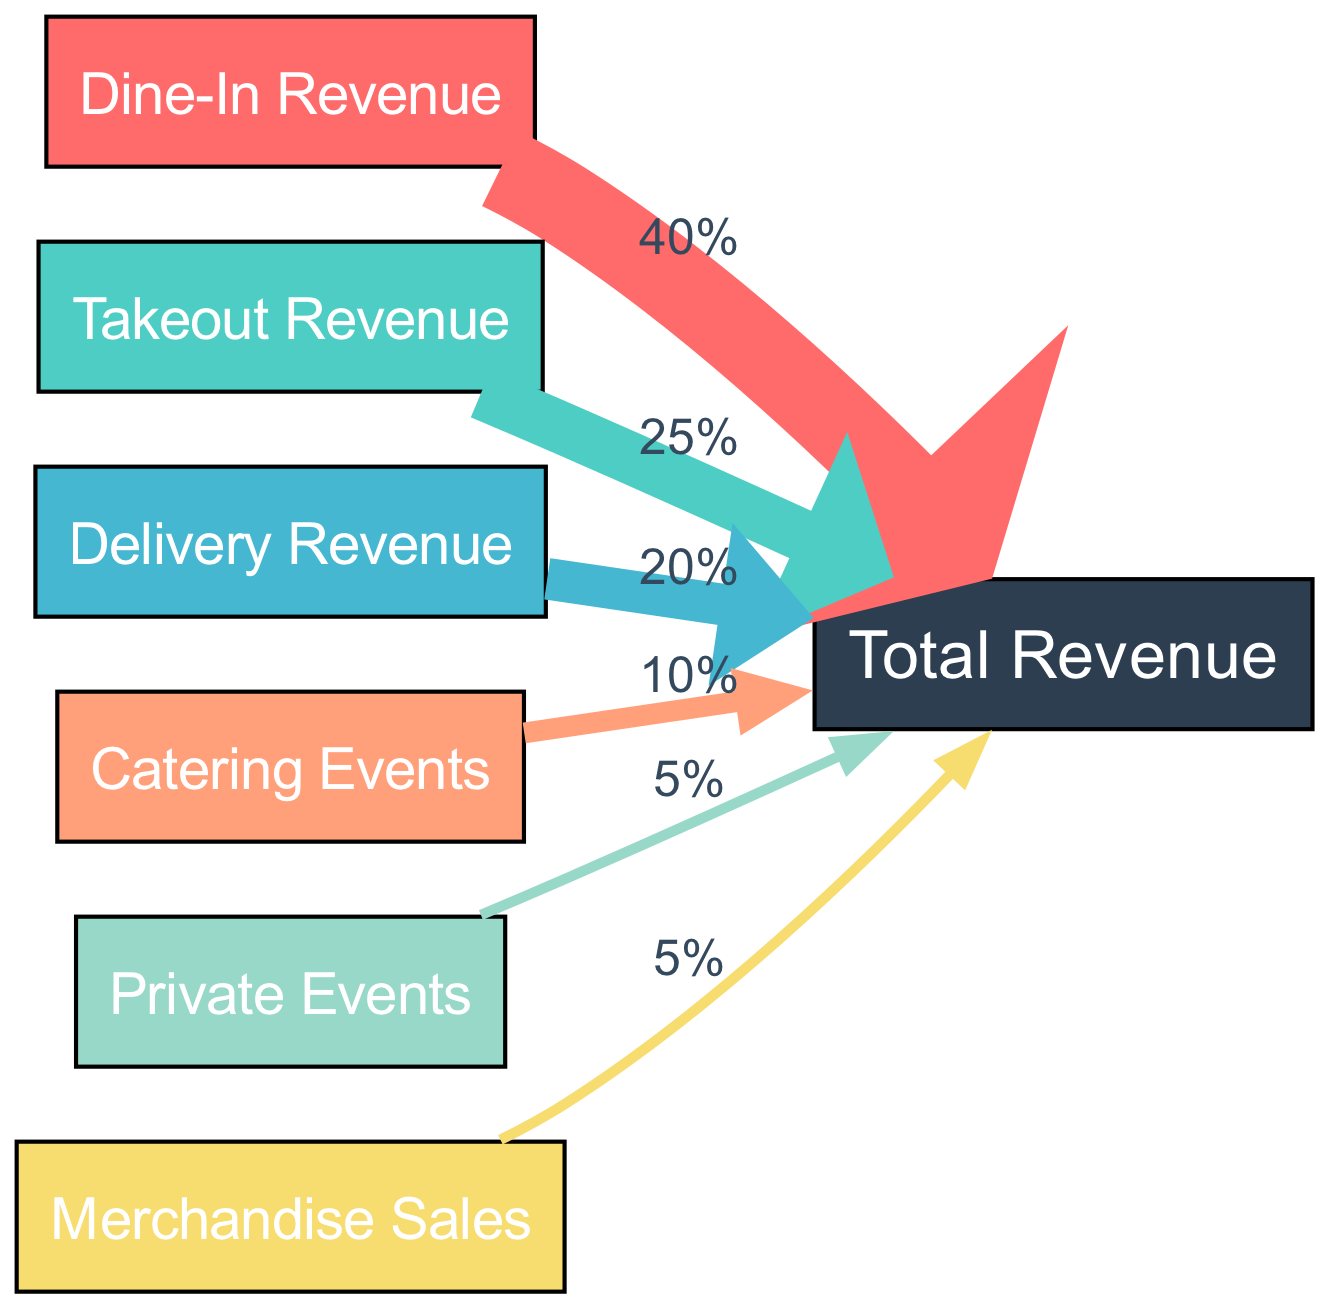What percentage of total revenue comes from dine-in revenue? The diagram indicates that dine-in revenue contributes 40% to total revenue, as shown by the link between the "Dine-In Revenue" node and "Total Revenue" node marked with the percentage value.
Answer: 40% How many revenue sources are shown in the diagram? The diagram contains six distinct nodes representing different sources of revenue: dine-in, takeout, delivery, catering events, private events, and merchandise sales. Counting these nodes gives a total of six revenue sources.
Answer: 6 Which revenue source has the lowest contribution to total revenue? Looking at the links connecting each source to total revenue, "Private Events" and "Merchandise Sales" both show a value of 5%, which is the lowest percentage compared to the other sources.
Answer: Private Events, Merchandise Sales What is the total percentage contribution of delivery revenue and catering events combined? Combining the contributions, delivery revenue is 20%, and catering events add another 10%, making the total 30%. This is calculated by adding the two individual percentages represented by the respective links to total revenue.
Answer: 30% Which income source contributes more: takeout or delivery? By comparing the percentages shown in the links, takeout revenue is at 25% and delivery revenue at 20%. The diagram clearly shows that takeout revenue contributes more to total revenue.
Answer: Takeout Revenue How much percentage does merchandise sales contribute to total revenue? The link from the "Merchandise Sales" node to the "Total Revenue" node shows a value of 5%, which indicates its contribution to the overall revenue of the restaurant.
Answer: 5% What is the combined percentage contribution of dine-in and takeout sources to total revenue? The contribution of dine-in revenue is 40%, and takeout revenue is 25%. Adding these two percentages gives a combined total of 65% for dine-in and takeout revenues, as represented in the diagram.
Answer: 65% 